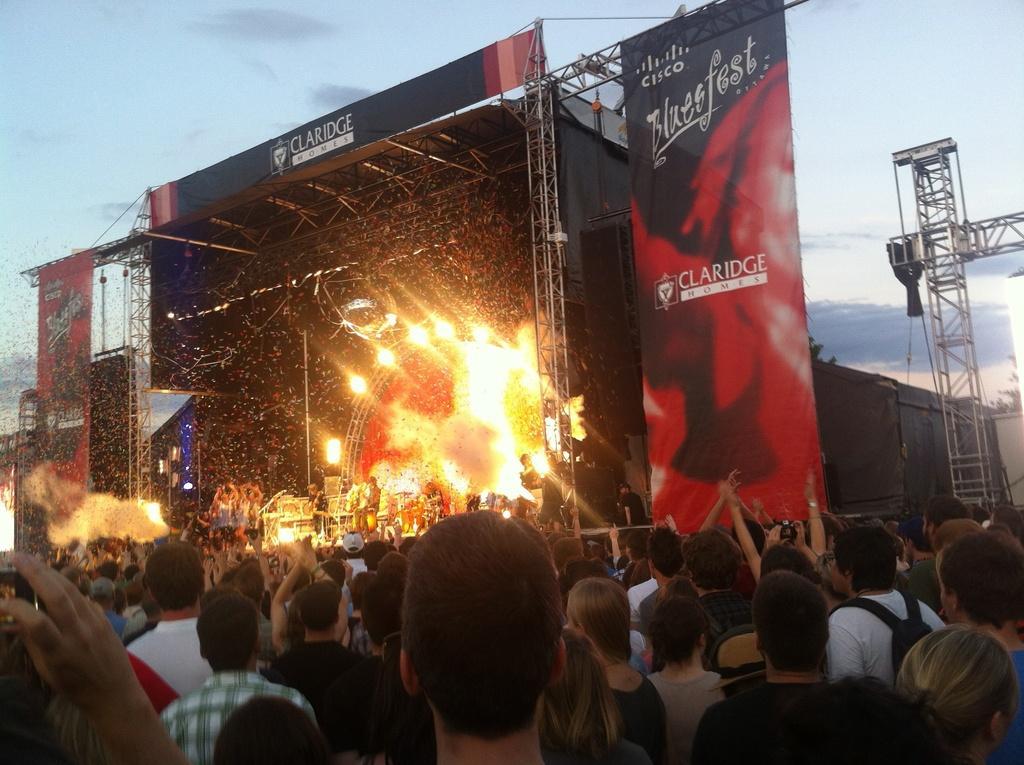In one or two sentences, can you explain what this image depicts? In this image, we can see the banners and there is a stage, there are some people performing on the stage, we can see some people standing and watching the performance, on the right side we can see a stand and at the top there is a sky. 